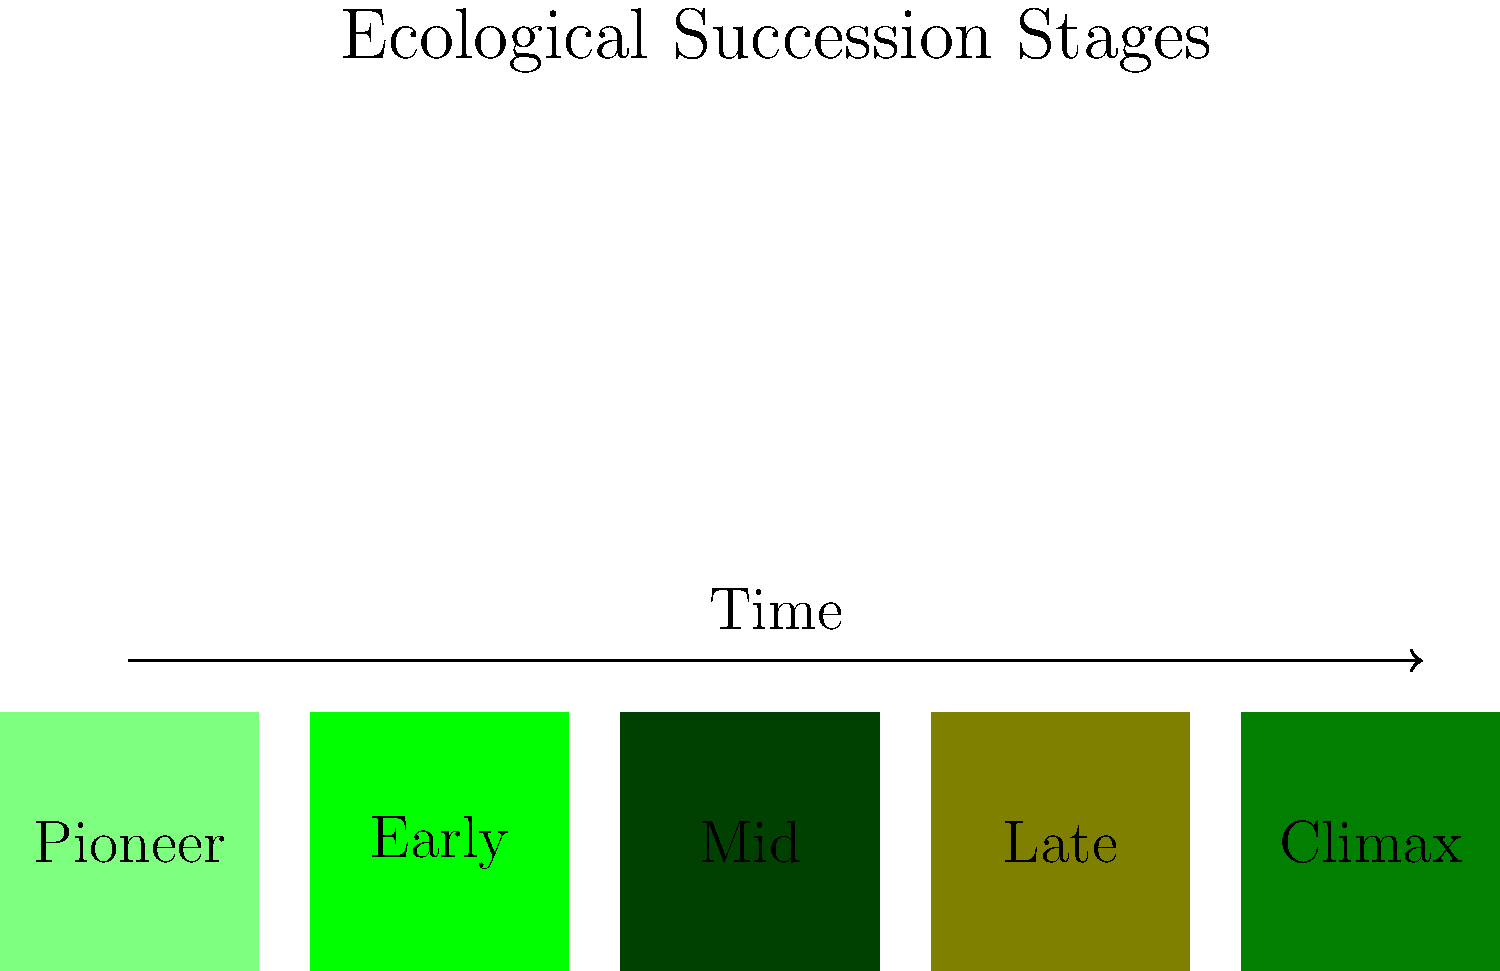In the ecological succession of a Ugandan forest ecosystem, which stage is characterized by the highest species diversity and most complex community structure? To answer this question, let's examine the stages of ecological succession in a Ugandan forest ecosystem:

1. Pioneer stage: This is the initial stage where hardy, fast-growing species colonize bare ground or disturbed areas. Species diversity is low.

2. Early succession stage: More plant species begin to establish, increasing diversity. The community structure is still relatively simple.

3. Mid-succession stage: A greater variety of plants and animals appear, further increasing diversity. The community structure becomes more complex.

4. Late succession stage: The ecosystem becomes more stable, with a high diversity of species and a complex community structure.

5. Climax stage: This is the final stage of succession, where the ecosystem reaches a relatively stable state. However, contrary to what might be expected, the climax stage often has slightly lower species diversity than the late succession stage.

The late succession stage typically exhibits the highest species diversity and most complex community structure. This is because:

a) It has had time to develop a wide variety of niches.
b) It supports a mix of early, middle, and late successional species.
c) The community structure is highly complex, with multiple layers in the forest canopy and a diverse understory.

While the climax stage is stable, it may have slightly lower diversity as some species are outcompeted in the final balance of the ecosystem.
Answer: Late succession stage 